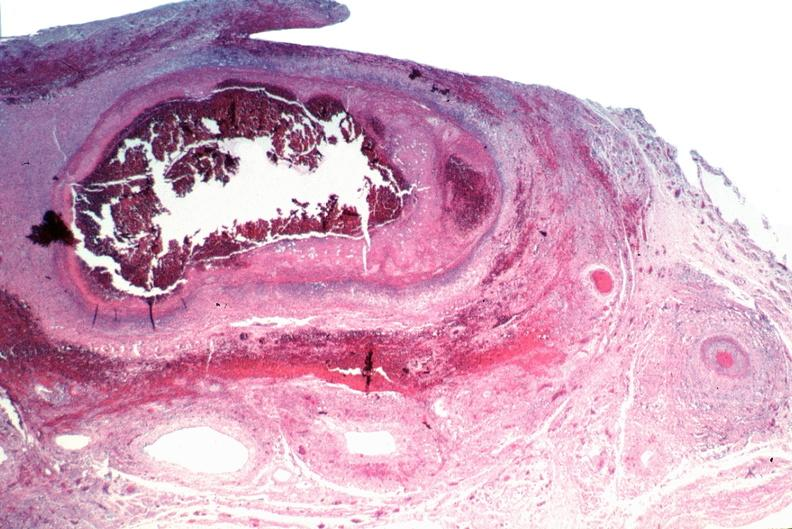s cardiovascular present?
Answer the question using a single word or phrase. Yes 